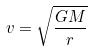Convert formula to latex. <formula><loc_0><loc_0><loc_500><loc_500>v = \sqrt { \frac { G M } { r } }</formula> 